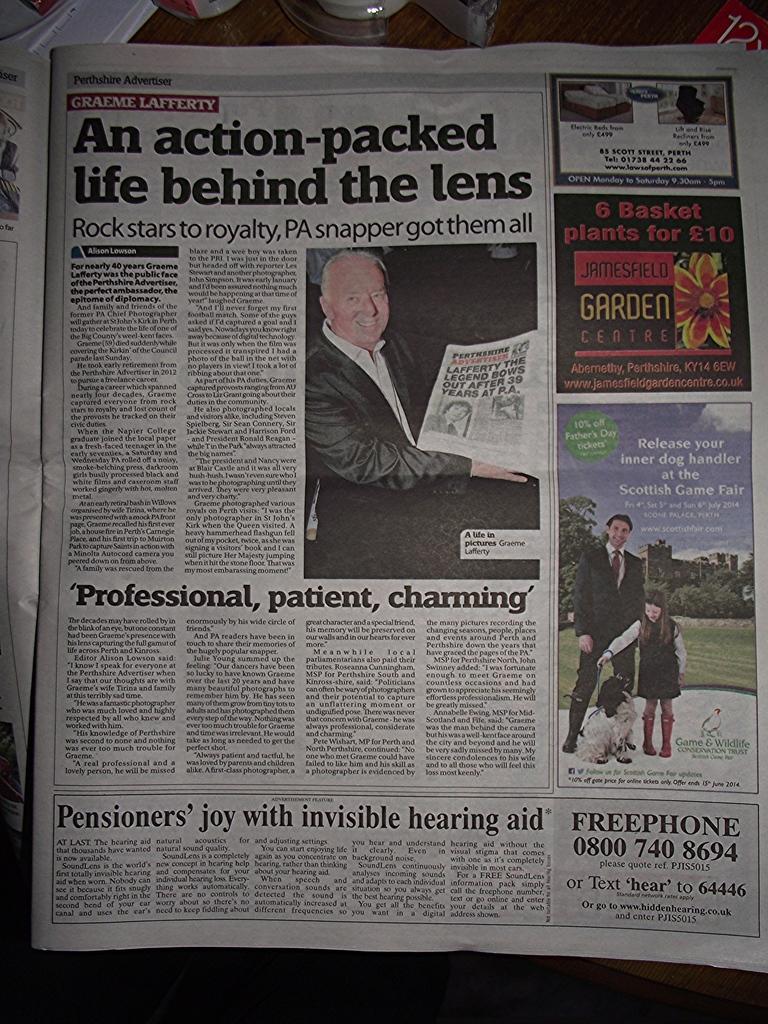Describe this image in one or two sentences. In this image there is a newspaper, there is text on the newspaper, there is a man standing, there is a girl standing, there is a dog, there is a man sitting, there is the sky,there are clouds in the sky, there is a building, there are trees, there is a flower, there are numbers on the news paper, there are objects towards the top of the image, at the background of the image there is an object that looks like a table. 